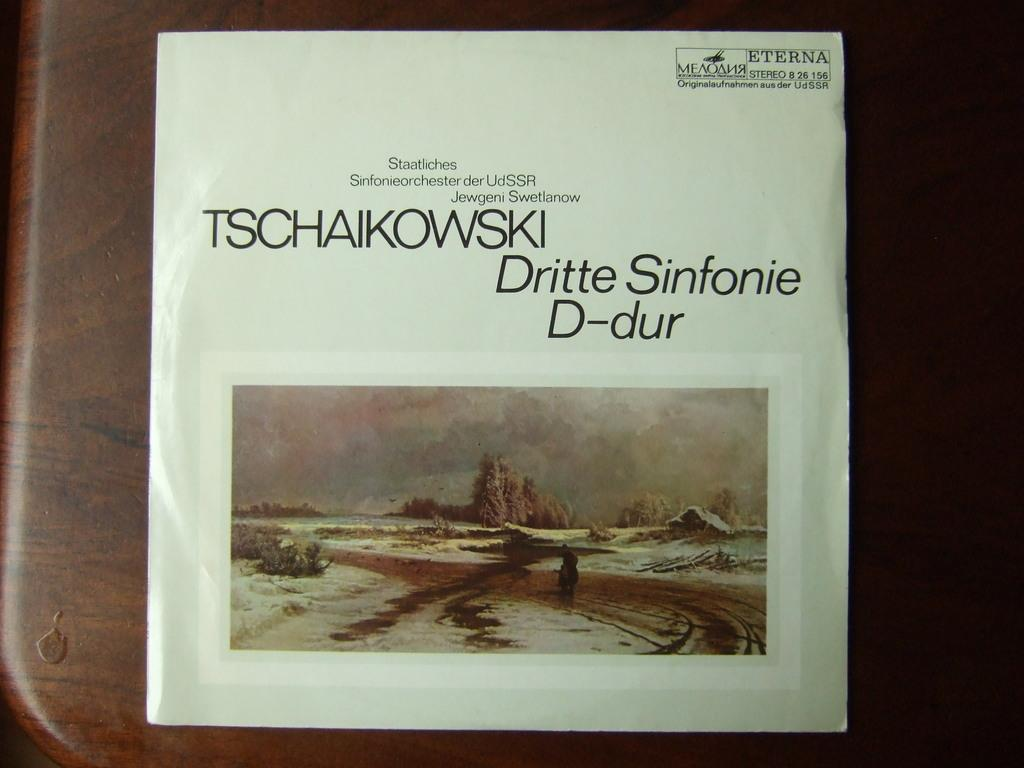What is present in the image that contains visual information? There is a paper in the image that contains images of hills. What else can be found on the paper besides the images of hills? There is text on the paper. What type of action can be seen being performed by the hills in the image? There is no action being performed by the hills in the image, as they are static images on the paper. 